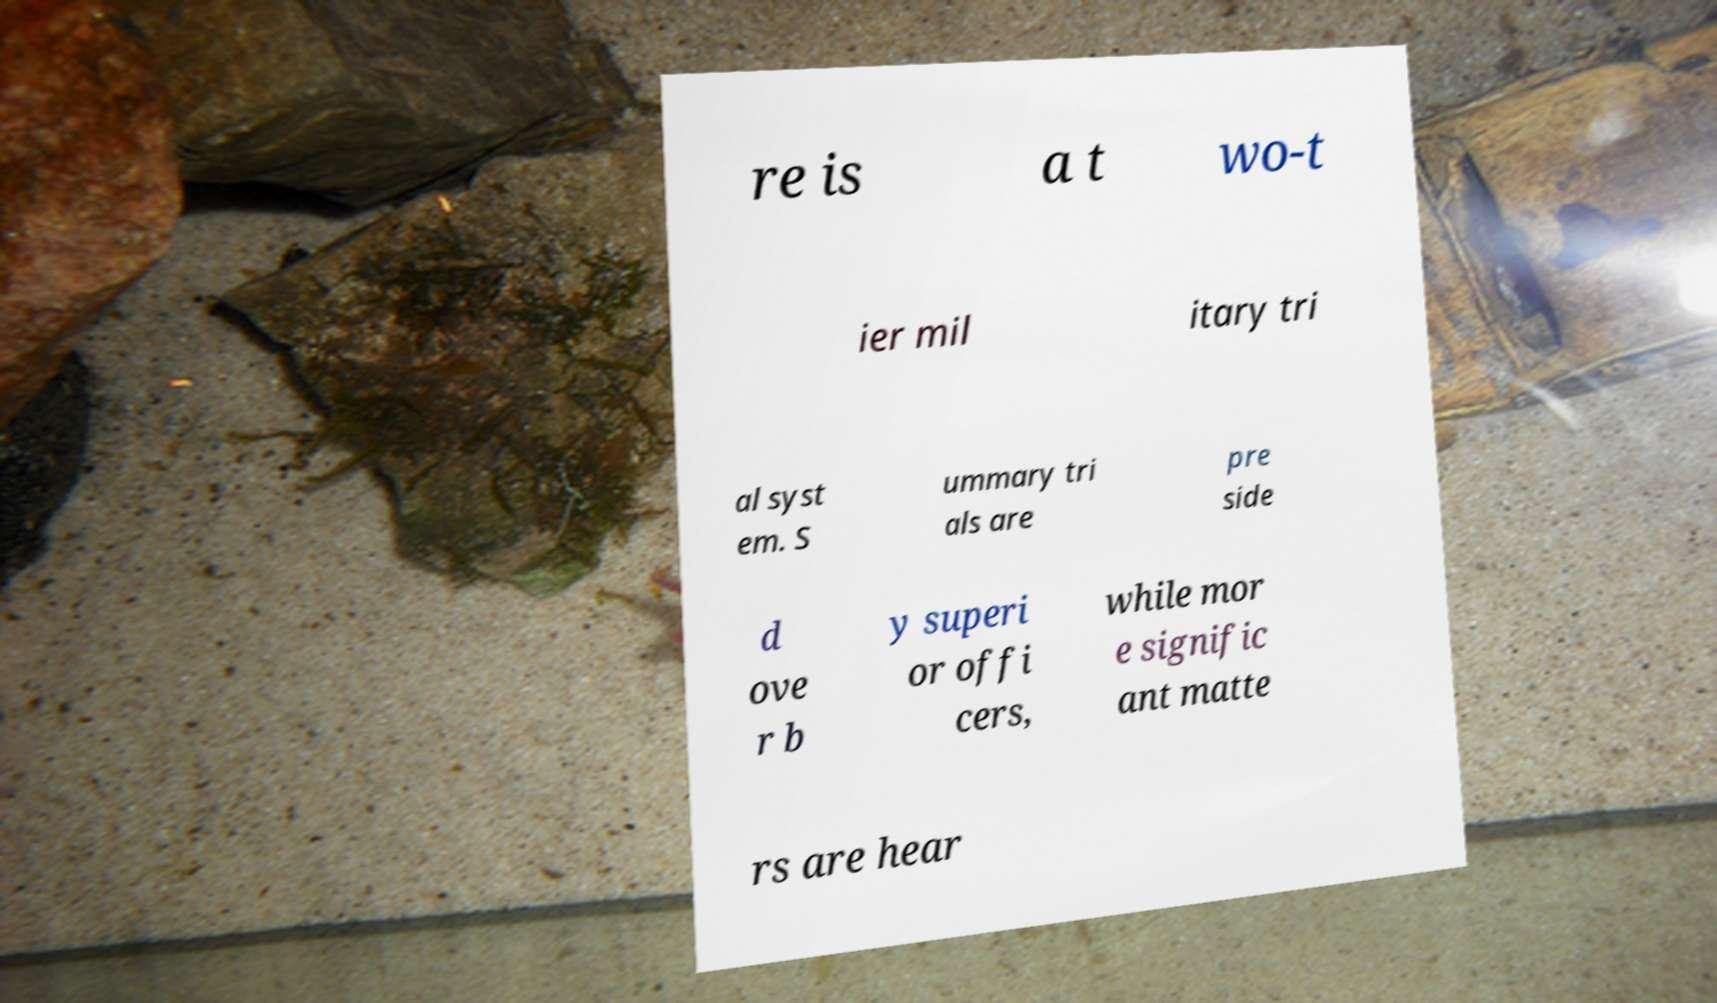There's text embedded in this image that I need extracted. Can you transcribe it verbatim? re is a t wo-t ier mil itary tri al syst em. S ummary tri als are pre side d ove r b y superi or offi cers, while mor e signific ant matte rs are hear 